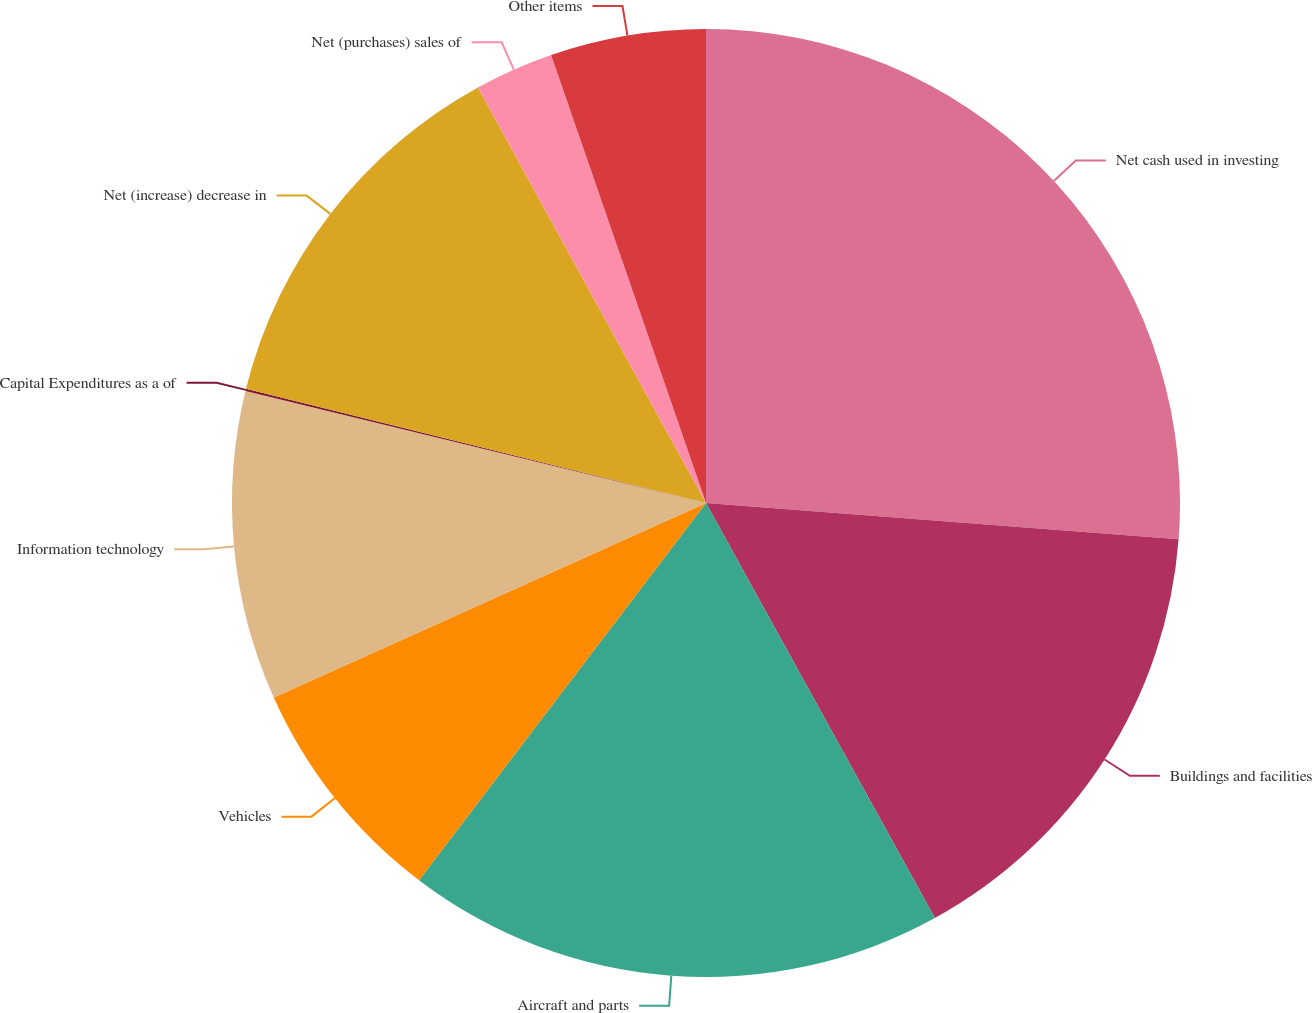Convert chart to OTSL. <chart><loc_0><loc_0><loc_500><loc_500><pie_chart><fcel>Net cash used in investing<fcel>Buildings and facilities<fcel>Aircraft and parts<fcel>Vehicles<fcel>Information technology<fcel>Capital Expenditures as a of<fcel>Net (increase) decrease in<fcel>Net (purchases) sales of<fcel>Other items<nl><fcel>26.22%<fcel>15.76%<fcel>18.37%<fcel>7.92%<fcel>10.53%<fcel>0.07%<fcel>13.14%<fcel>2.69%<fcel>5.3%<nl></chart> 